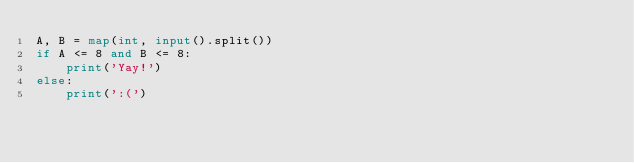Convert code to text. <code><loc_0><loc_0><loc_500><loc_500><_Python_>A, B = map(int, input().split())
if A <= 8 and B <= 8:
    print('Yay!')
else:
    print(':(')</code> 